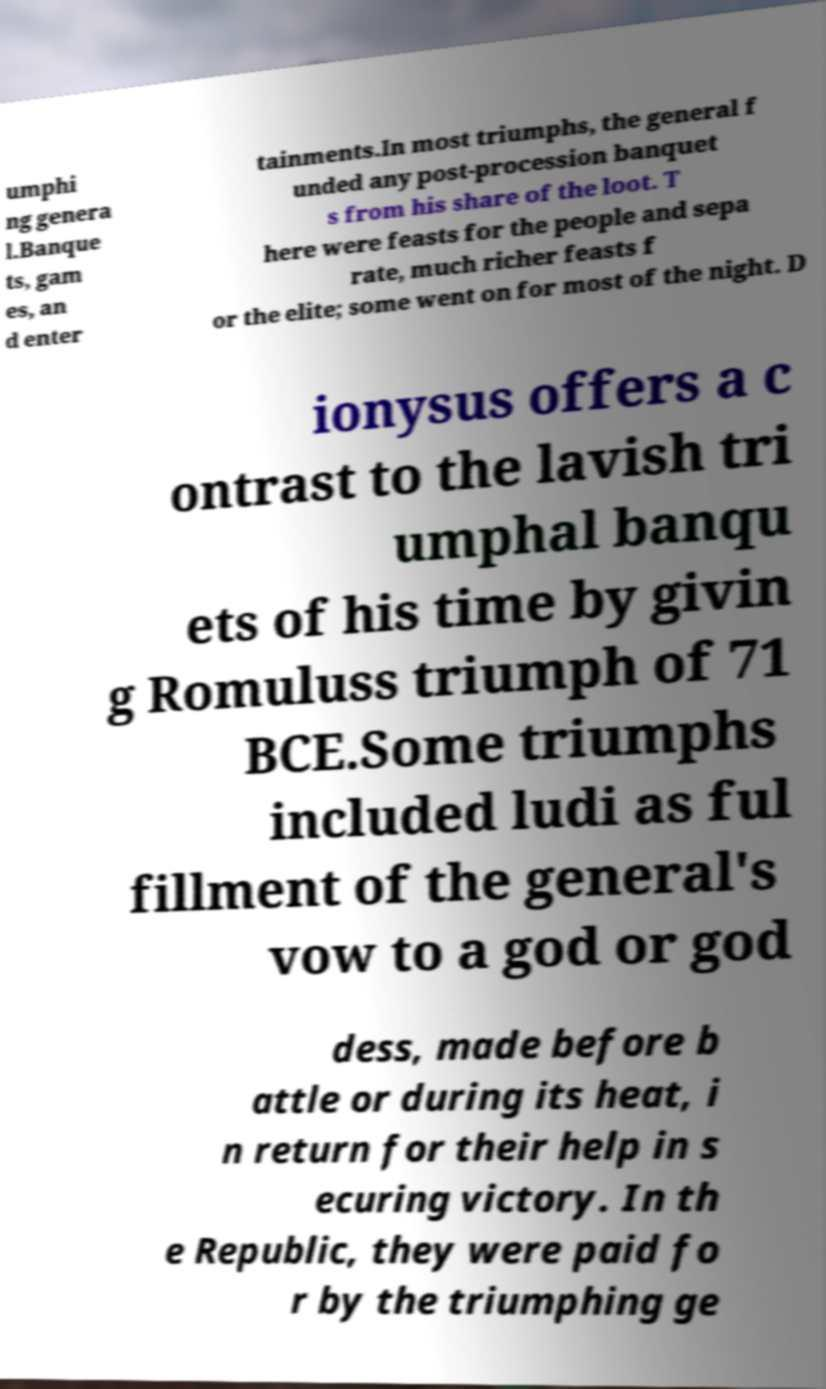Please identify and transcribe the text found in this image. umphi ng genera l.Banque ts, gam es, an d enter tainments.In most triumphs, the general f unded any post-procession banquet s from his share of the loot. T here were feasts for the people and sepa rate, much richer feasts f or the elite; some went on for most of the night. D ionysus offers a c ontrast to the lavish tri umphal banqu ets of his time by givin g Romuluss triumph of 71 BCE.Some triumphs included ludi as ful fillment of the general's vow to a god or god dess, made before b attle or during its heat, i n return for their help in s ecuring victory. In th e Republic, they were paid fo r by the triumphing ge 